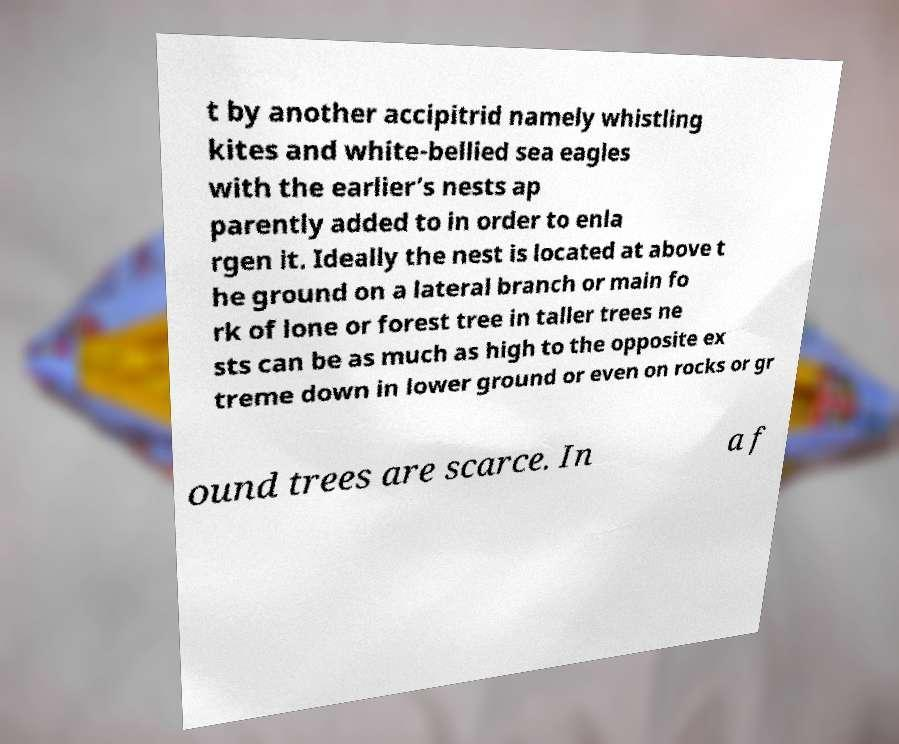I need the written content from this picture converted into text. Can you do that? t by another accipitrid namely whistling kites and white-bellied sea eagles with the earlier’s nests ap parently added to in order to enla rgen it. Ideally the nest is located at above t he ground on a lateral branch or main fo rk of lone or forest tree in taller trees ne sts can be as much as high to the opposite ex treme down in lower ground or even on rocks or gr ound trees are scarce. In a f 